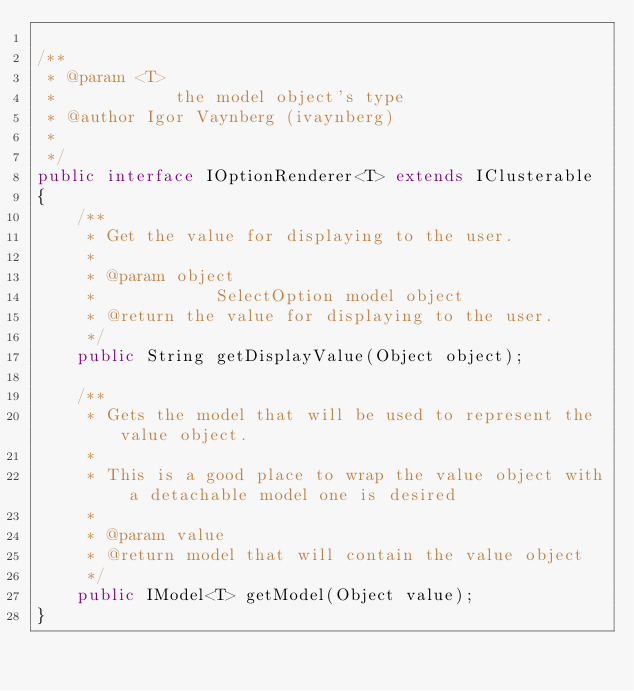Convert code to text. <code><loc_0><loc_0><loc_500><loc_500><_Java_>
/**
 * @param <T>
 *            the model object's type
 * @author Igor Vaynberg (ivaynberg)
 * 
 */
public interface IOptionRenderer<T> extends IClusterable
{
	/**
	 * Get the value for displaying to the user.
	 * 
	 * @param object
	 *            SelectOption model object
	 * @return the value for displaying to the user.
	 */
	public String getDisplayValue(Object object);

	/**
	 * Gets the model that will be used to represent the value object.
	 * 
	 * This is a good place to wrap the value object with a detachable model one is desired
	 * 
	 * @param value
	 * @return model that will contain the value object
	 */
	public IModel<T> getModel(Object value);
}
</code> 